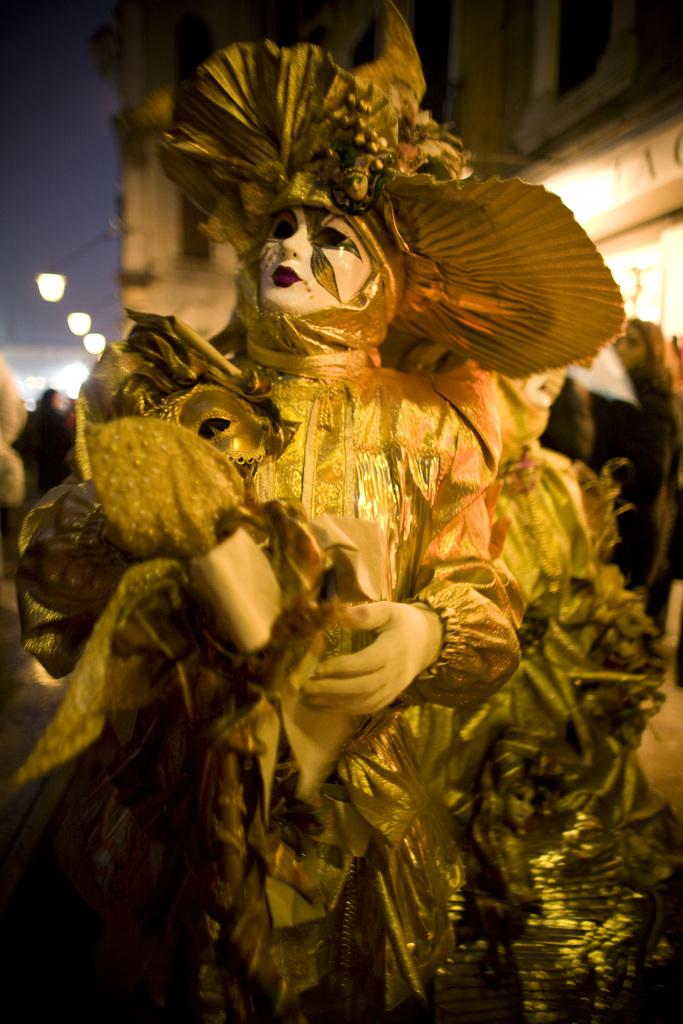What is the main subject of the image? There is a woman in the image. What is the woman doing in the image? The woman is standing. What is the woman wearing in the image? The woman is wearing a costume. What can be seen in the background of the image? There are buildings, people standing on the road, electric lights, and the sky visible in the background. What type of breakfast is the woman eating in the image? There is no indication in the image that the woman is eating breakfast, so it cannot be determined from the picture. 